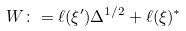Convert formula to latex. <formula><loc_0><loc_0><loc_500><loc_500>W \colon = \ell ( \xi ^ { \prime } ) \Delta ^ { 1 / 2 } + \ell ( \xi ) ^ { * }</formula> 